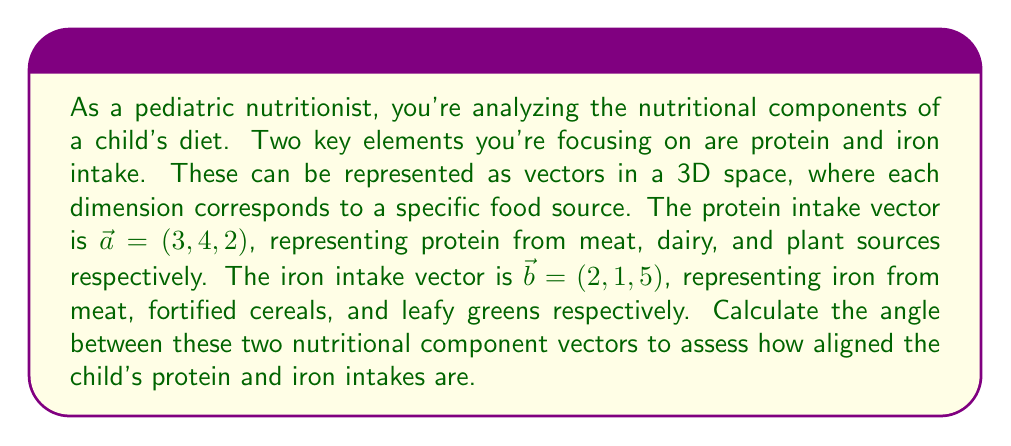Provide a solution to this math problem. To find the angle between two vectors, we can use the dot product formula:

$$\cos \theta = \frac{\vec{a} \cdot \vec{b}}{|\vec{a}||\vec{b}|}$$

Where $\theta$ is the angle between the vectors, $\vec{a} \cdot \vec{b}$ is the dot product of the vectors, and $|\vec{a}|$ and $|\vec{b}|$ are the magnitudes of the vectors.

Step 1: Calculate the dot product $\vec{a} \cdot \vec{b}$
$$\vec{a} \cdot \vec{b} = (3)(2) + (4)(1) + (2)(5) = 6 + 4 + 10 = 20$$

Step 2: Calculate the magnitudes of the vectors
$$|\vec{a}| = \sqrt{3^2 + 4^2 + 2^2} = \sqrt{9 + 16 + 4} = \sqrt{29}$$
$$|\vec{b}| = \sqrt{2^2 + 1^2 + 5^2} = \sqrt{4 + 1 + 25} = \sqrt{30}$$

Step 3: Apply the dot product formula
$$\cos \theta = \frac{20}{\sqrt{29}\sqrt{30}}$$

Step 4: Calculate the angle by taking the inverse cosine (arccos)
$$\theta = \arccos(\frac{20}{\sqrt{29}\sqrt{30}})$$

Step 5: Convert to degrees
$$\theta = \arccos(\frac{20}{\sqrt{29}\sqrt{30}}) \cdot \frac{180°}{\pi}$$
Answer: $\theta \approx 41.41°$ 